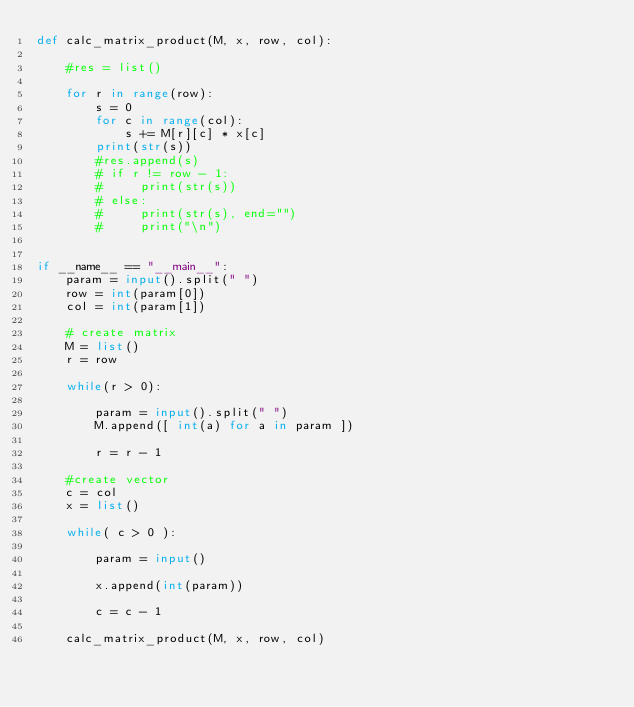Convert code to text. <code><loc_0><loc_0><loc_500><loc_500><_Python_>def calc_matrix_product(M, x, row, col):

    #res = list()

    for r in range(row):
        s = 0
        for c in range(col):
            s += M[r][c] * x[c]
        print(str(s))
        #res.append(s)
        # if r != row - 1:
        #     print(str(s))
        # else:
        #     print(str(s), end="")
        #     print("\n")


if __name__ == "__main__":
    param = input().split(" ")
    row = int(param[0])
    col = int(param[1])

    # create matrix
    M = list()
    r = row

    while(r > 0):

        param = input().split(" ")
        M.append([ int(a) for a in param ])

        r = r - 1

    #create vector
    c = col
    x = list()

    while( c > 0 ):

        param = input()

        x.append(int(param))

        c = c - 1

    calc_matrix_product(M, x, row, col)
</code> 